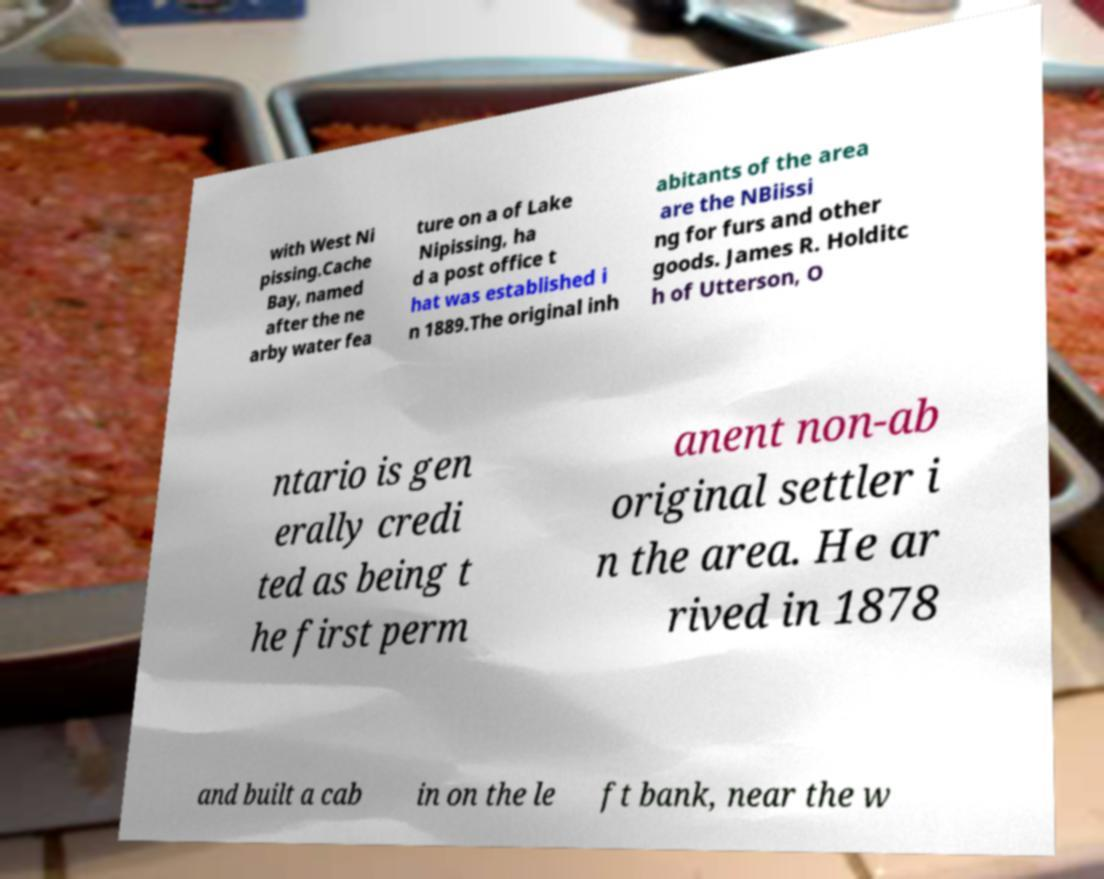Who was James R. Holditch and what is his significance in this document? James R. Holditch, mentioned in the document as one of the first permanent non-aboriginal settlers, arrived in the area around Cache Bay in 1878 and is known for building a cabin on the left bank. 